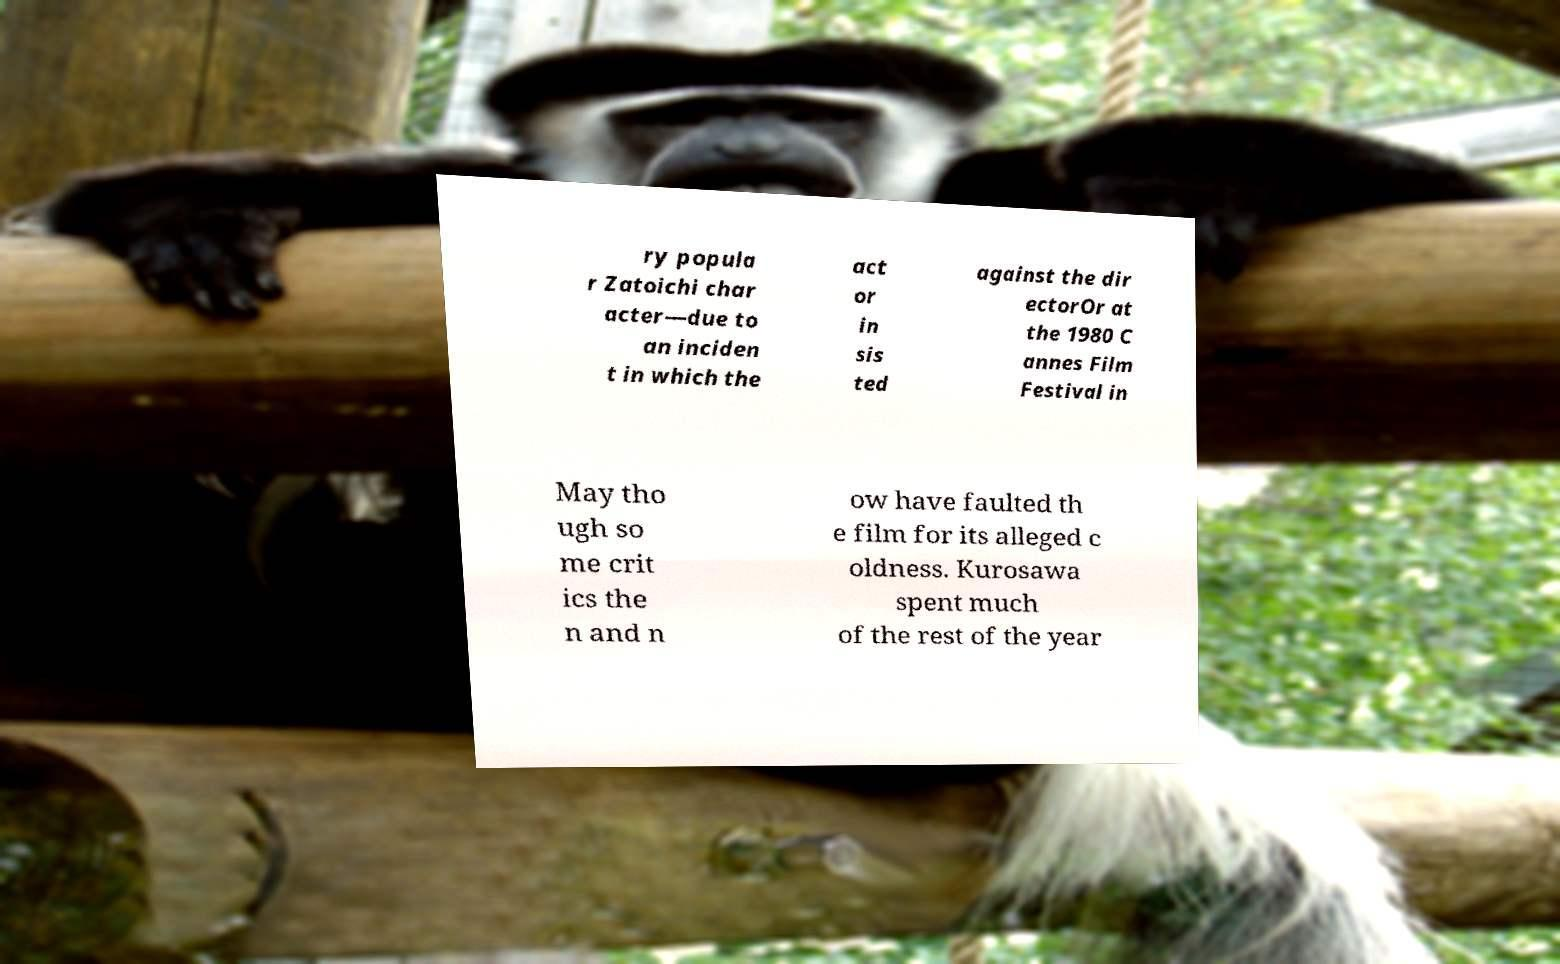What messages or text are displayed in this image? I need them in a readable, typed format. ry popula r Zatoichi char acter—due to an inciden t in which the act or in sis ted against the dir ectorOr at the 1980 C annes Film Festival in May tho ugh so me crit ics the n and n ow have faulted th e film for its alleged c oldness. Kurosawa spent much of the rest of the year 